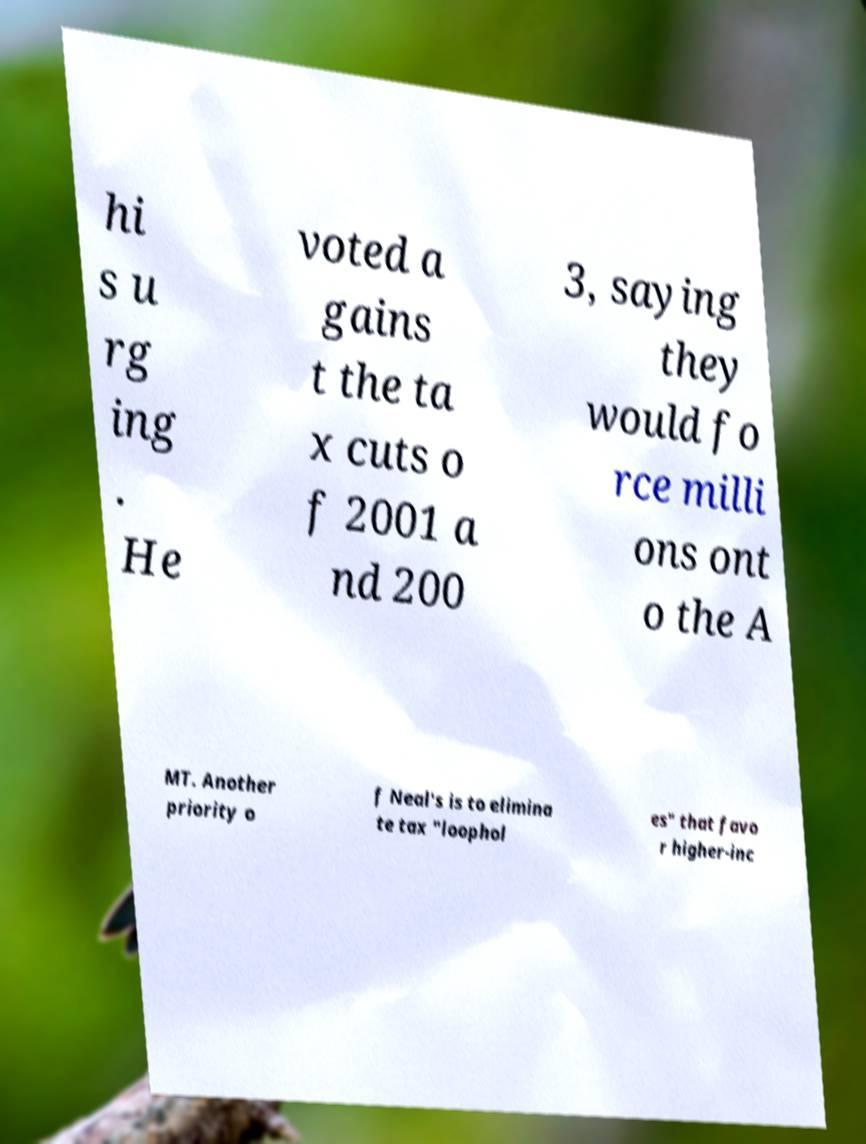I need the written content from this picture converted into text. Can you do that? hi s u rg ing . He voted a gains t the ta x cuts o f 2001 a nd 200 3, saying they would fo rce milli ons ont o the A MT. Another priority o f Neal's is to elimina te tax "loophol es" that favo r higher-inc 